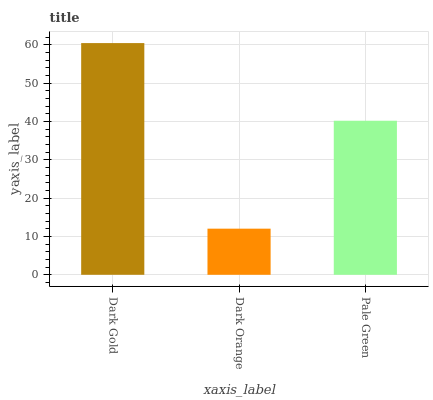Is Dark Orange the minimum?
Answer yes or no. Yes. Is Dark Gold the maximum?
Answer yes or no. Yes. Is Pale Green the minimum?
Answer yes or no. No. Is Pale Green the maximum?
Answer yes or no. No. Is Pale Green greater than Dark Orange?
Answer yes or no. Yes. Is Dark Orange less than Pale Green?
Answer yes or no. Yes. Is Dark Orange greater than Pale Green?
Answer yes or no. No. Is Pale Green less than Dark Orange?
Answer yes or no. No. Is Pale Green the high median?
Answer yes or no. Yes. Is Pale Green the low median?
Answer yes or no. Yes. Is Dark Gold the high median?
Answer yes or no. No. Is Dark Gold the low median?
Answer yes or no. No. 